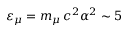Convert formula to latex. <formula><loc_0><loc_0><loc_500><loc_500>\varepsilon _ { \mu } = m _ { \mu } \, c ^ { 2 } \alpha ^ { 2 } \sim 5</formula> 